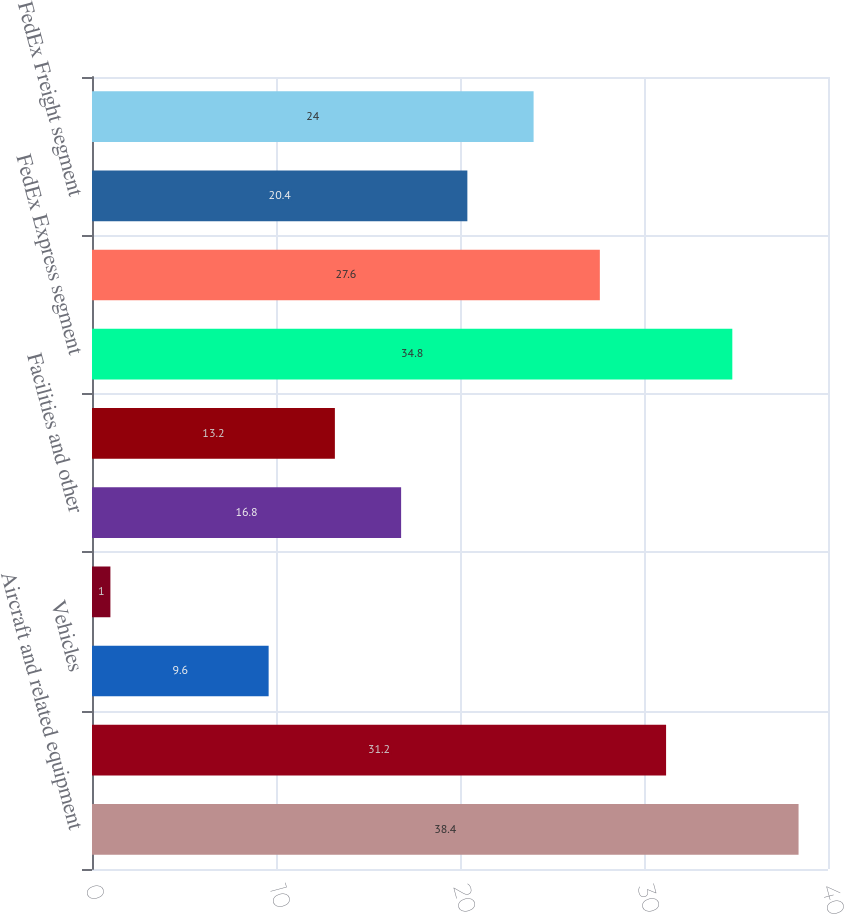Convert chart. <chart><loc_0><loc_0><loc_500><loc_500><bar_chart><fcel>Aircraft and related equipment<fcel>Package handling and ground<fcel>Vehicles<fcel>Information technology<fcel>Facilities and other<fcel>Total capital expenditures<fcel>FedEx Express segment<fcel>FedEx Ground segment<fcel>FedEx Freight segment<fcel>FedEx Services segment<nl><fcel>38.4<fcel>31.2<fcel>9.6<fcel>1<fcel>16.8<fcel>13.2<fcel>34.8<fcel>27.6<fcel>20.4<fcel>24<nl></chart> 